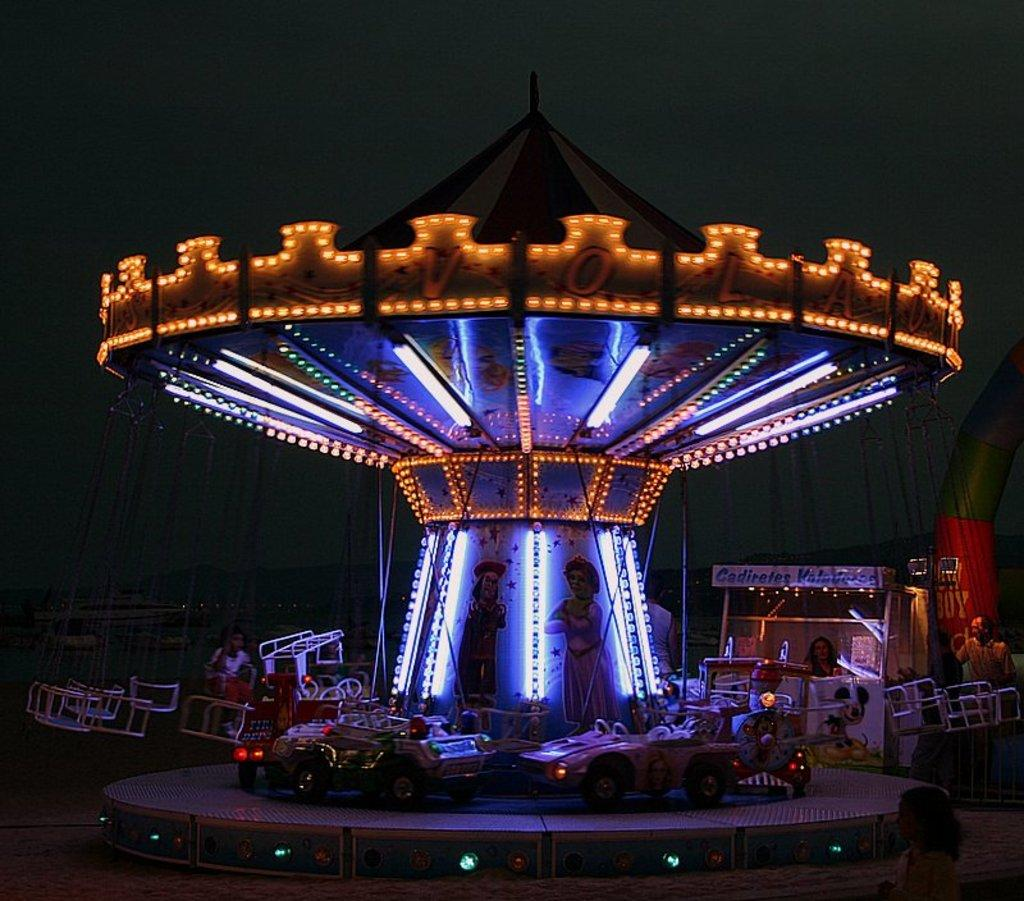What type of vehicles are in the image? There are cars in the image. Can you describe the person in the image? There is a person in the image. What can be seen in the background of the image? The sky is visible in the image. What type of underwear is the person wearing in the image? There is no information about the person's underwear in the image, so it cannot be determined. 